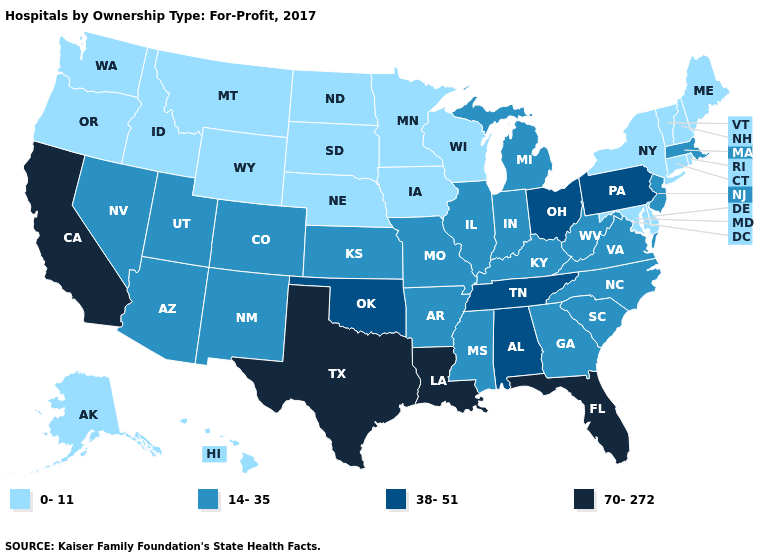Name the states that have a value in the range 70-272?
Quick response, please. California, Florida, Louisiana, Texas. Is the legend a continuous bar?
Concise answer only. No. Name the states that have a value in the range 14-35?
Short answer required. Arizona, Arkansas, Colorado, Georgia, Illinois, Indiana, Kansas, Kentucky, Massachusetts, Michigan, Mississippi, Missouri, Nevada, New Jersey, New Mexico, North Carolina, South Carolina, Utah, Virginia, West Virginia. What is the value of West Virginia?
Short answer required. 14-35. Does the first symbol in the legend represent the smallest category?
Concise answer only. Yes. What is the value of Colorado?
Answer briefly. 14-35. What is the value of Connecticut?
Concise answer only. 0-11. Which states have the highest value in the USA?
Quick response, please. California, Florida, Louisiana, Texas. Does Florida have a lower value than Tennessee?
Give a very brief answer. No. What is the value of New York?
Keep it brief. 0-11. Among the states that border New York , does Connecticut have the highest value?
Give a very brief answer. No. Name the states that have a value in the range 38-51?
Quick response, please. Alabama, Ohio, Oklahoma, Pennsylvania, Tennessee. Does Maine have a lower value than Idaho?
Keep it brief. No. What is the lowest value in the South?
Answer briefly. 0-11. What is the value of Michigan?
Be succinct. 14-35. 